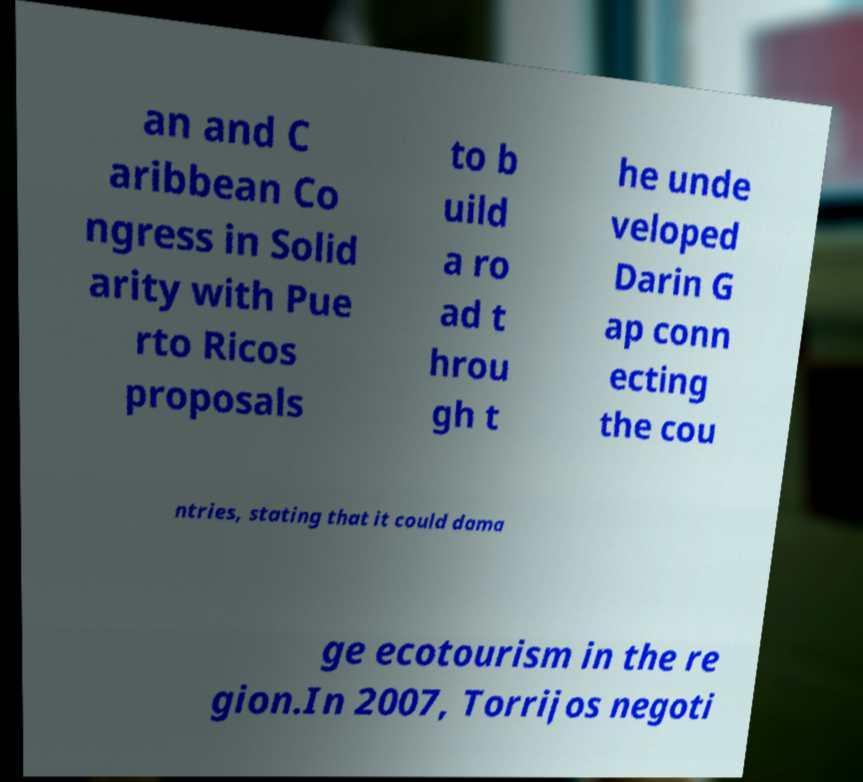Could you extract and type out the text from this image? an and C aribbean Co ngress in Solid arity with Pue rto Ricos proposals to b uild a ro ad t hrou gh t he unde veloped Darin G ap conn ecting the cou ntries, stating that it could dama ge ecotourism in the re gion.In 2007, Torrijos negoti 